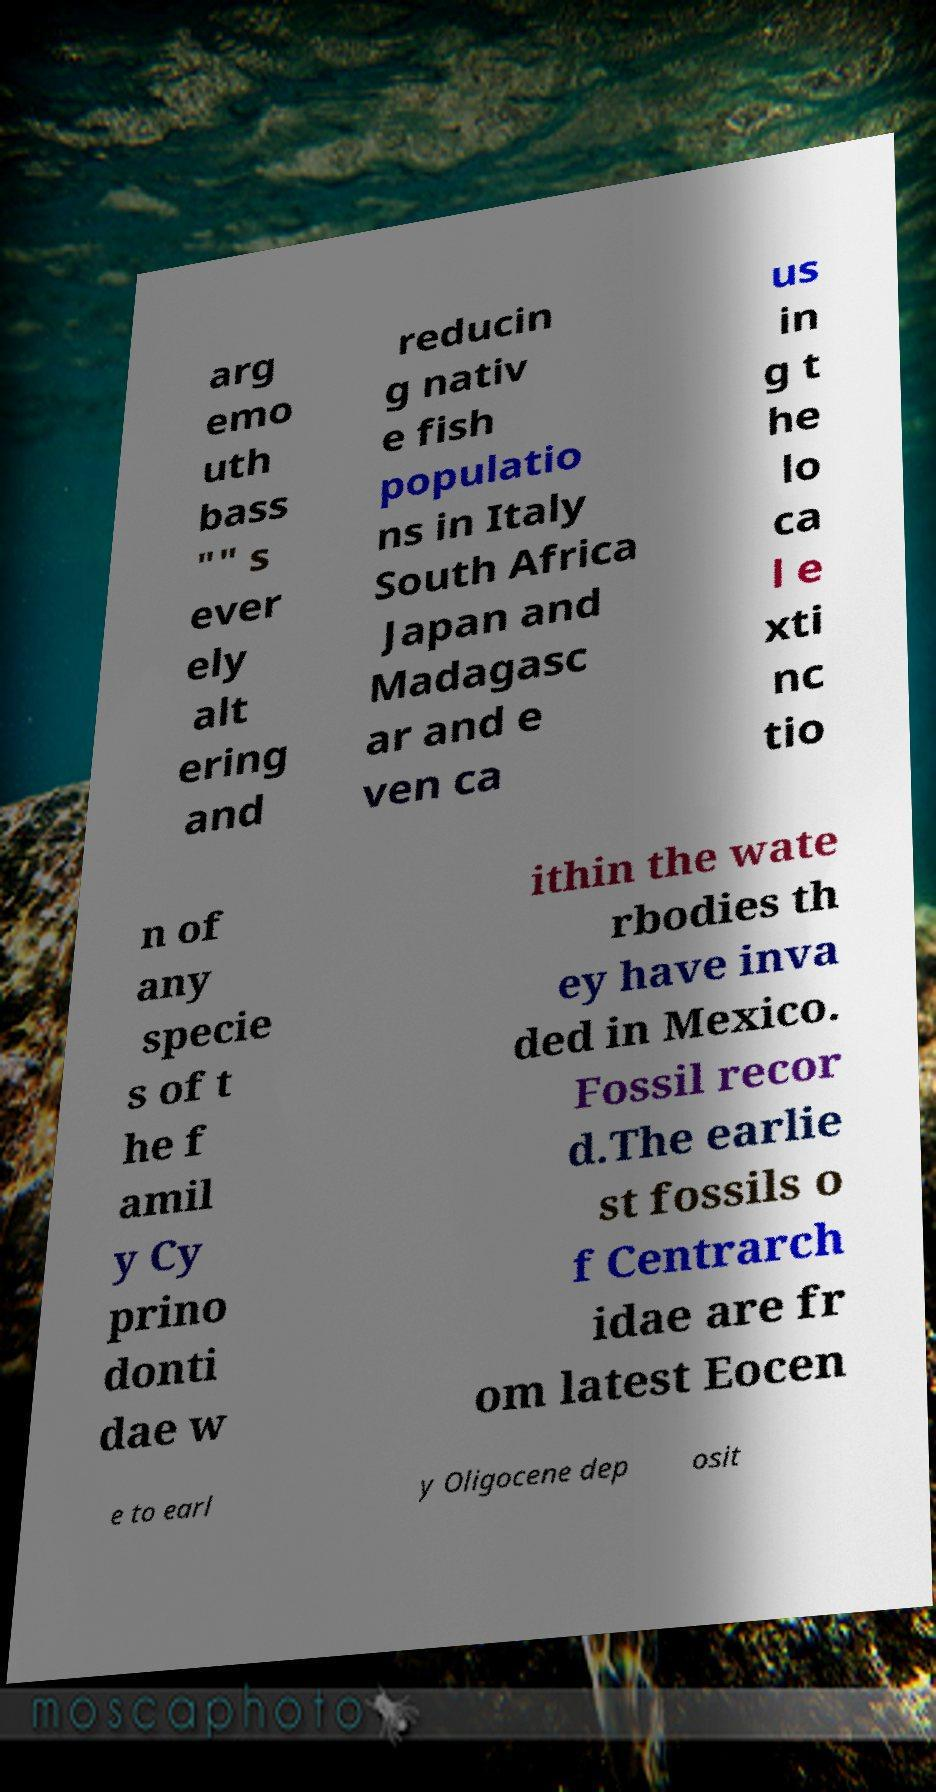Please read and relay the text visible in this image. What does it say? arg emo uth bass "" s ever ely alt ering and reducin g nativ e fish populatio ns in Italy South Africa Japan and Madagasc ar and e ven ca us in g t he lo ca l e xti nc tio n of any specie s of t he f amil y Cy prino donti dae w ithin the wate rbodies th ey have inva ded in Mexico. Fossil recor d.The earlie st fossils o f Centrarch idae are fr om latest Eocen e to earl y Oligocene dep osit 